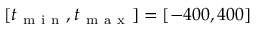<formula> <loc_0><loc_0><loc_500><loc_500>[ t _ { m i n } , t _ { m a x } ] = [ - 4 0 0 , 4 0 0 ]</formula> 